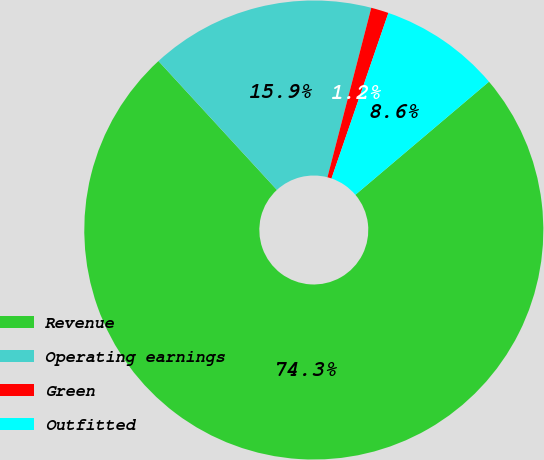Convert chart. <chart><loc_0><loc_0><loc_500><loc_500><pie_chart><fcel>Revenue<fcel>Operating earnings<fcel>Green<fcel>Outfitted<nl><fcel>74.35%<fcel>15.86%<fcel>1.24%<fcel>8.55%<nl></chart> 